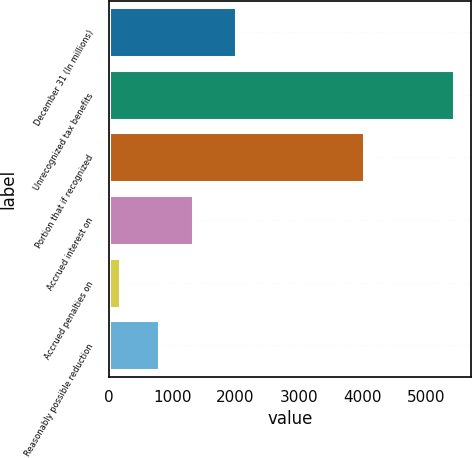Convert chart. <chart><loc_0><loc_0><loc_500><loc_500><bar_chart><fcel>December 31 (In millions)<fcel>Unrecognized tax benefits<fcel>Portion that if recognized<fcel>Accrued interest on<fcel>Accrued penalties on<fcel>Reasonably possible reduction<nl><fcel>2012<fcel>5445<fcel>4032<fcel>1327.2<fcel>173<fcel>800<nl></chart> 